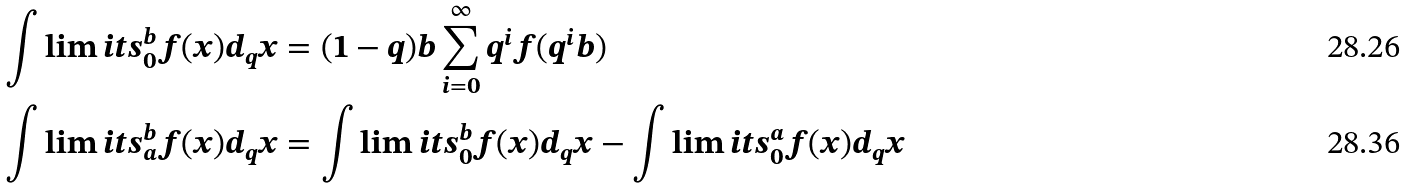<formula> <loc_0><loc_0><loc_500><loc_500>\int \lim i t s _ { 0 } ^ { b } f ( x ) d _ { q } x & = ( 1 - q ) b \sum _ { i = 0 } ^ { \infty } q ^ { i } f ( q ^ { i } b ) \\ \int \lim i t s _ { a } ^ { b } f ( x ) d _ { q } x & = \int \lim i t s _ { 0 } ^ { b } f ( x ) d _ { q } x - \int \lim i t s _ { 0 } ^ { a } f ( x ) d _ { q } x</formula> 